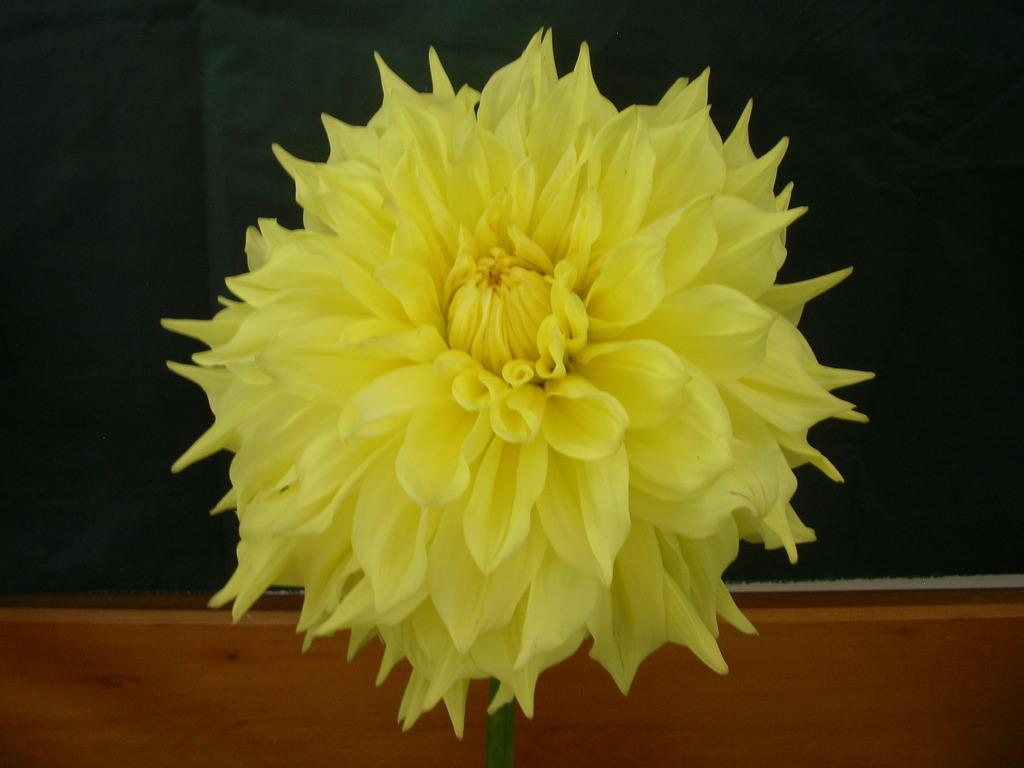What type of flower is present in the image? There is a yellow color flower in the image. What letters can be seen on the flower in the image? There are no letters present on the flower in the image. What type of mouth is visible on the flower in the image? Flowers do not have mouths, so there is no mouth visible on the flower in the image. 